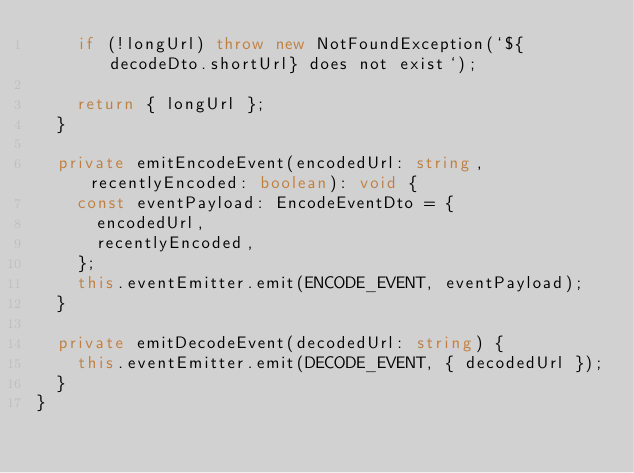<code> <loc_0><loc_0><loc_500><loc_500><_TypeScript_>    if (!longUrl) throw new NotFoundException(`${decodeDto.shortUrl} does not exist`);

    return { longUrl };
  }

  private emitEncodeEvent(encodedUrl: string, recentlyEncoded: boolean): void {
    const eventPayload: EncodeEventDto = {
      encodedUrl,
      recentlyEncoded,
    };
    this.eventEmitter.emit(ENCODE_EVENT, eventPayload);
  }

  private emitDecodeEvent(decodedUrl: string) {
    this.eventEmitter.emit(DECODE_EVENT, { decodedUrl });
  }
}
</code> 